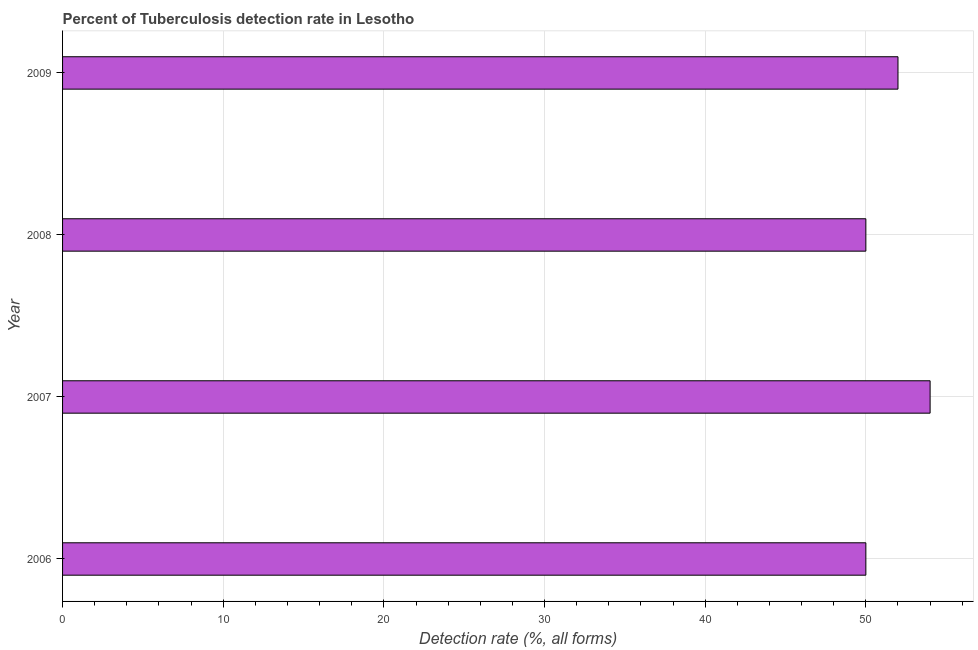Does the graph contain any zero values?
Provide a succinct answer. No. What is the title of the graph?
Give a very brief answer. Percent of Tuberculosis detection rate in Lesotho. What is the label or title of the X-axis?
Offer a very short reply. Detection rate (%, all forms). What is the label or title of the Y-axis?
Ensure brevity in your answer.  Year. What is the detection rate of tuberculosis in 2007?
Keep it short and to the point. 54. Across all years, what is the maximum detection rate of tuberculosis?
Keep it short and to the point. 54. In which year was the detection rate of tuberculosis maximum?
Give a very brief answer. 2007. What is the sum of the detection rate of tuberculosis?
Your answer should be very brief. 206. What is the ratio of the detection rate of tuberculosis in 2006 to that in 2007?
Make the answer very short. 0.93. Is the difference between the detection rate of tuberculosis in 2006 and 2007 greater than the difference between any two years?
Your response must be concise. Yes. What is the difference between the highest and the lowest detection rate of tuberculosis?
Your response must be concise. 4. How many bars are there?
Your answer should be compact. 4. Are all the bars in the graph horizontal?
Provide a succinct answer. Yes. What is the difference between two consecutive major ticks on the X-axis?
Your response must be concise. 10. What is the Detection rate (%, all forms) in 2007?
Keep it short and to the point. 54. What is the Detection rate (%, all forms) of 2008?
Your response must be concise. 50. What is the difference between the Detection rate (%, all forms) in 2007 and 2008?
Provide a succinct answer. 4. What is the difference between the Detection rate (%, all forms) in 2007 and 2009?
Provide a succinct answer. 2. What is the difference between the Detection rate (%, all forms) in 2008 and 2009?
Give a very brief answer. -2. What is the ratio of the Detection rate (%, all forms) in 2006 to that in 2007?
Offer a very short reply. 0.93. What is the ratio of the Detection rate (%, all forms) in 2007 to that in 2008?
Provide a short and direct response. 1.08. What is the ratio of the Detection rate (%, all forms) in 2007 to that in 2009?
Your response must be concise. 1.04. What is the ratio of the Detection rate (%, all forms) in 2008 to that in 2009?
Offer a terse response. 0.96. 